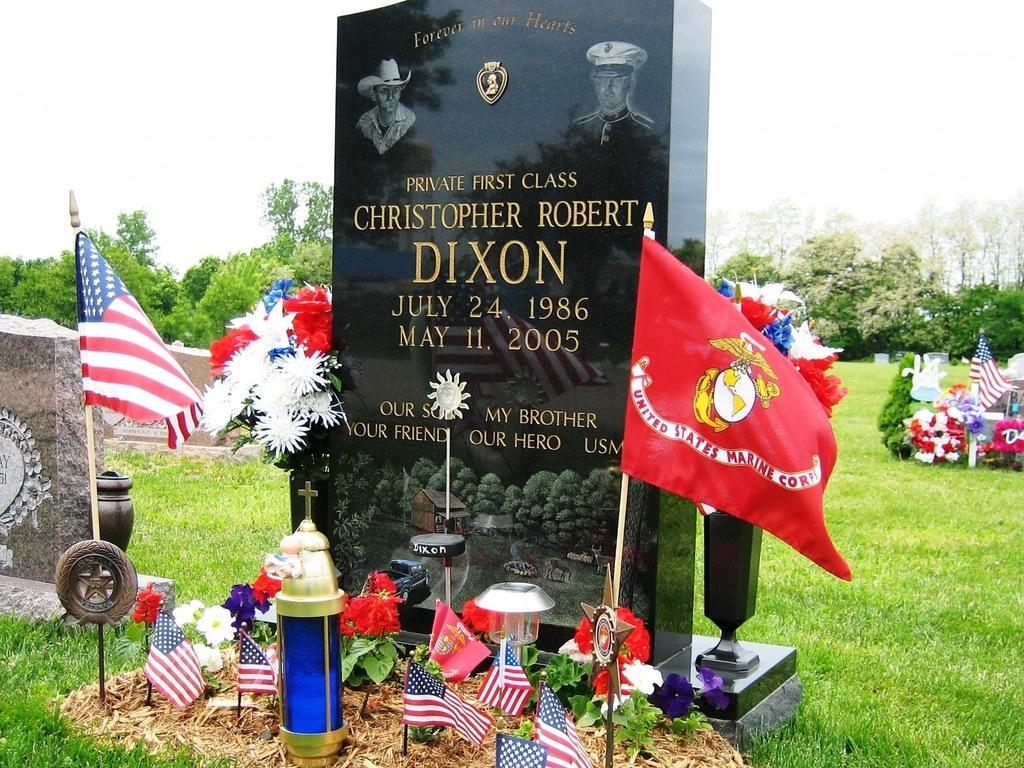What is the main subject in the center of the image? There is a grave in the center of the image. What can be seen on both sides of the grave? There are flags on both sides of the grave. What type of vegetation is visible in the background of the image? There is grass in the background of the image. What else can be seen in the background of the image? There are trees and the sky visible in the background of the image. Can you tell me how many goldfish are swimming in the grave? There are no goldfish present in the image; it features a grave with flags and a natural background. 